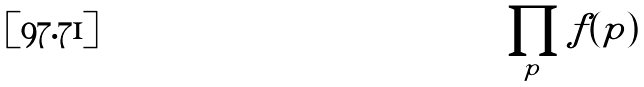<formula> <loc_0><loc_0><loc_500><loc_500>\prod _ { p } f ( p )</formula> 